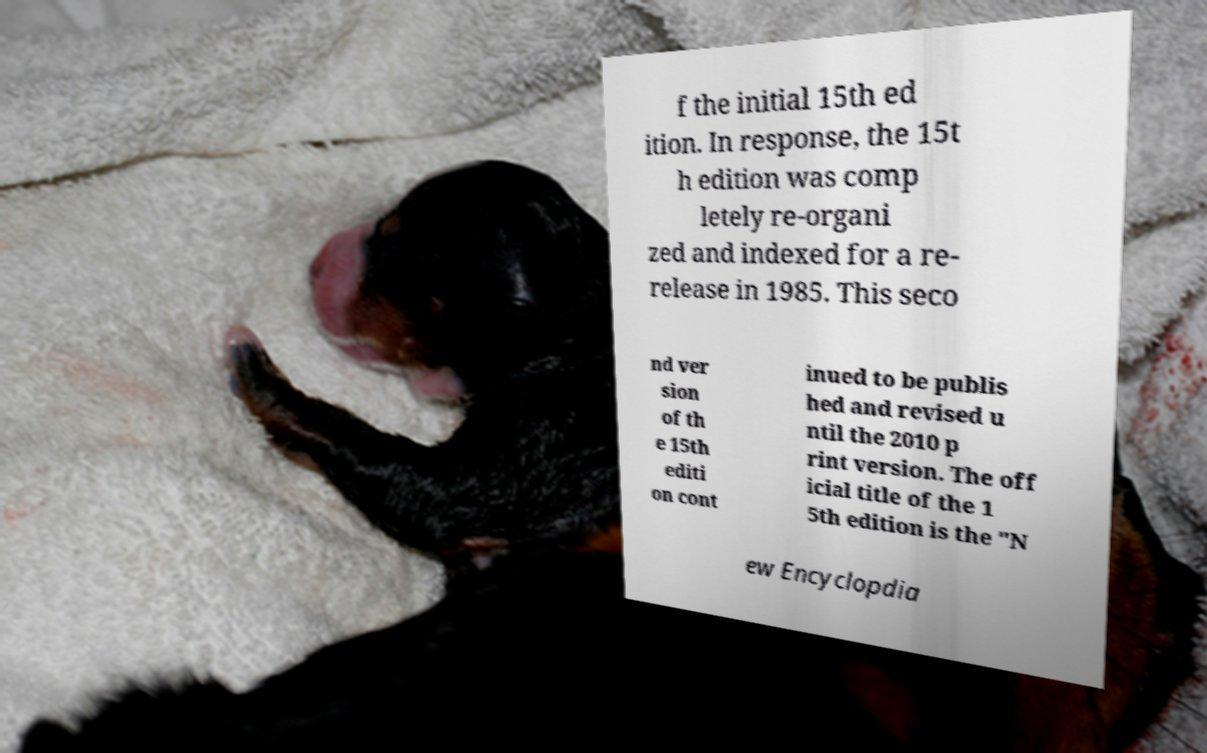For documentation purposes, I need the text within this image transcribed. Could you provide that? f the initial 15th ed ition. In response, the 15t h edition was comp letely re-organi zed and indexed for a re- release in 1985. This seco nd ver sion of th e 15th editi on cont inued to be publis hed and revised u ntil the 2010 p rint version. The off icial title of the 1 5th edition is the "N ew Encyclopdia 